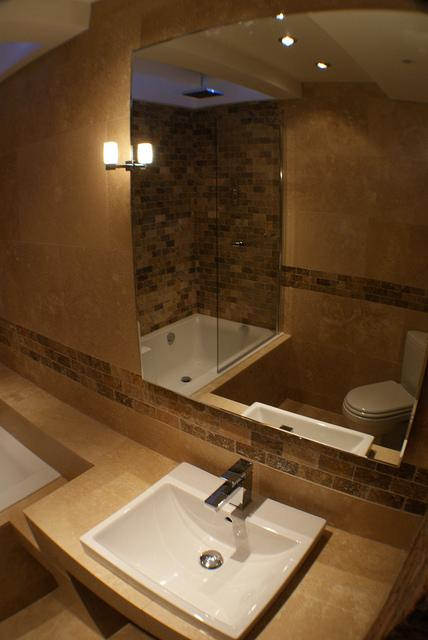Why is there no shower curtain? Please explain your reasoning. shower door. It has a glass enclosure so there is no need for anything else. 